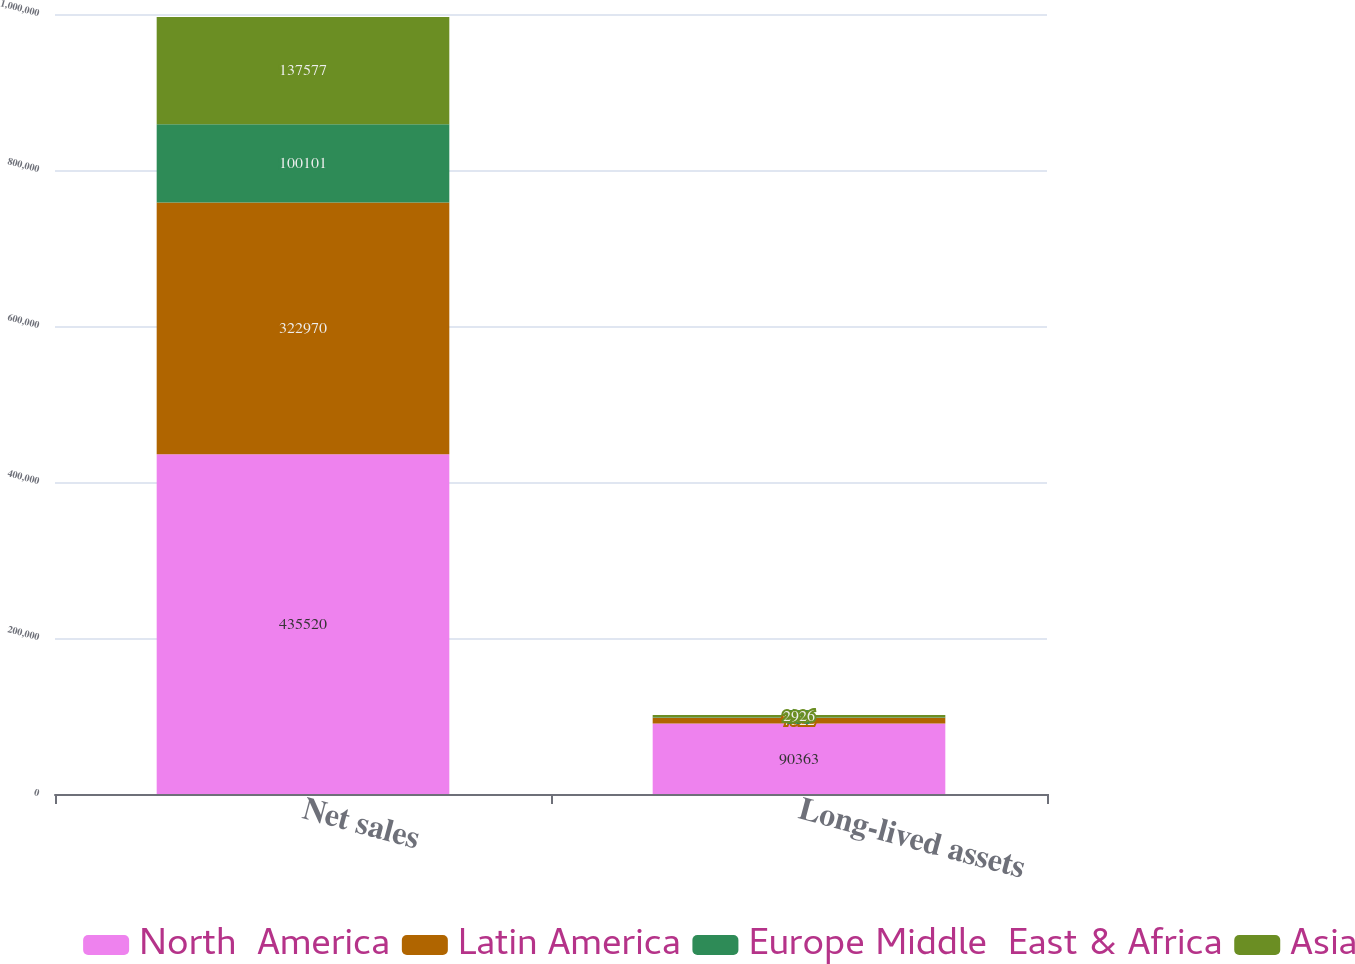Convert chart to OTSL. <chart><loc_0><loc_0><loc_500><loc_500><stacked_bar_chart><ecel><fcel>Net sales<fcel>Long-lived assets<nl><fcel>North  America<fcel>435520<fcel>90363<nl><fcel>Latin America<fcel>322970<fcel>7522<nl><fcel>Europe Middle  East & Africa<fcel>100101<fcel>538<nl><fcel>Asia<fcel>137577<fcel>2926<nl></chart> 